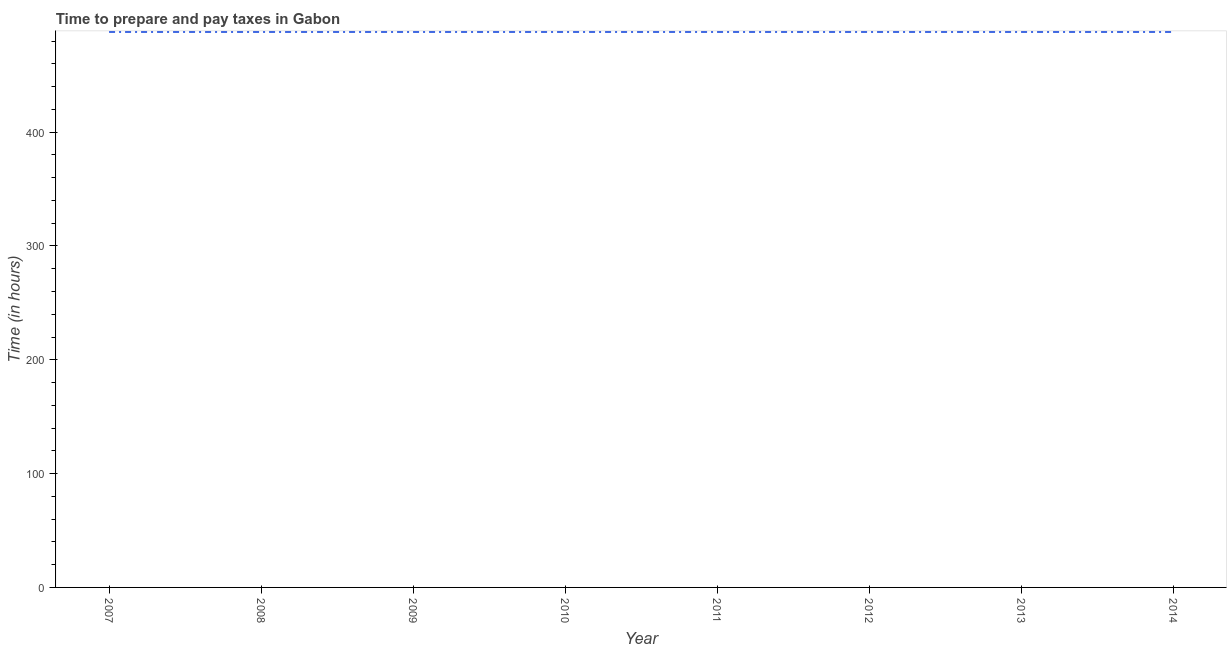What is the time to prepare and pay taxes in 2014?
Offer a very short reply. 488. Across all years, what is the maximum time to prepare and pay taxes?
Offer a very short reply. 488. Across all years, what is the minimum time to prepare and pay taxes?
Offer a very short reply. 488. In which year was the time to prepare and pay taxes maximum?
Provide a succinct answer. 2007. What is the sum of the time to prepare and pay taxes?
Your response must be concise. 3904. What is the average time to prepare and pay taxes per year?
Give a very brief answer. 488. What is the median time to prepare and pay taxes?
Give a very brief answer. 488. In how many years, is the time to prepare and pay taxes greater than 420 hours?
Your response must be concise. 8. Do a majority of the years between 2009 and 2011 (inclusive) have time to prepare and pay taxes greater than 260 hours?
Make the answer very short. Yes. What is the ratio of the time to prepare and pay taxes in 2008 to that in 2014?
Offer a terse response. 1. Is the time to prepare and pay taxes in 2009 less than that in 2011?
Give a very brief answer. No. What is the difference between the highest and the lowest time to prepare and pay taxes?
Ensure brevity in your answer.  0. How many years are there in the graph?
Provide a succinct answer. 8. Does the graph contain any zero values?
Ensure brevity in your answer.  No. What is the title of the graph?
Offer a very short reply. Time to prepare and pay taxes in Gabon. What is the label or title of the X-axis?
Your answer should be compact. Year. What is the label or title of the Y-axis?
Give a very brief answer. Time (in hours). What is the Time (in hours) of 2007?
Give a very brief answer. 488. What is the Time (in hours) of 2008?
Give a very brief answer. 488. What is the Time (in hours) in 2009?
Provide a short and direct response. 488. What is the Time (in hours) of 2010?
Your answer should be compact. 488. What is the Time (in hours) of 2011?
Provide a short and direct response. 488. What is the Time (in hours) in 2012?
Provide a short and direct response. 488. What is the Time (in hours) in 2013?
Your answer should be compact. 488. What is the Time (in hours) of 2014?
Offer a very short reply. 488. What is the difference between the Time (in hours) in 2007 and 2010?
Provide a succinct answer. 0. What is the difference between the Time (in hours) in 2007 and 2011?
Provide a succinct answer. 0. What is the difference between the Time (in hours) in 2007 and 2012?
Provide a succinct answer. 0. What is the difference between the Time (in hours) in 2007 and 2013?
Provide a succinct answer. 0. What is the difference between the Time (in hours) in 2008 and 2009?
Provide a succinct answer. 0. What is the difference between the Time (in hours) in 2008 and 2010?
Your answer should be very brief. 0. What is the difference between the Time (in hours) in 2008 and 2011?
Give a very brief answer. 0. What is the difference between the Time (in hours) in 2008 and 2012?
Ensure brevity in your answer.  0. What is the difference between the Time (in hours) in 2008 and 2013?
Your answer should be very brief. 0. What is the difference between the Time (in hours) in 2009 and 2014?
Offer a very short reply. 0. What is the difference between the Time (in hours) in 2010 and 2011?
Make the answer very short. 0. What is the difference between the Time (in hours) in 2010 and 2013?
Your response must be concise. 0. What is the difference between the Time (in hours) in 2011 and 2014?
Provide a short and direct response. 0. What is the difference between the Time (in hours) in 2012 and 2013?
Your answer should be very brief. 0. What is the difference between the Time (in hours) in 2012 and 2014?
Your answer should be very brief. 0. What is the ratio of the Time (in hours) in 2007 to that in 2010?
Ensure brevity in your answer.  1. What is the ratio of the Time (in hours) in 2007 to that in 2011?
Your response must be concise. 1. What is the ratio of the Time (in hours) in 2007 to that in 2012?
Make the answer very short. 1. What is the ratio of the Time (in hours) in 2007 to that in 2013?
Make the answer very short. 1. What is the ratio of the Time (in hours) in 2007 to that in 2014?
Your answer should be very brief. 1. What is the ratio of the Time (in hours) in 2008 to that in 2011?
Offer a very short reply. 1. What is the ratio of the Time (in hours) in 2008 to that in 2013?
Offer a very short reply. 1. What is the ratio of the Time (in hours) in 2008 to that in 2014?
Keep it short and to the point. 1. What is the ratio of the Time (in hours) in 2009 to that in 2011?
Offer a terse response. 1. What is the ratio of the Time (in hours) in 2009 to that in 2012?
Offer a terse response. 1. What is the ratio of the Time (in hours) in 2009 to that in 2013?
Offer a terse response. 1. What is the ratio of the Time (in hours) in 2010 to that in 2011?
Your response must be concise. 1. What is the ratio of the Time (in hours) in 2010 to that in 2012?
Provide a succinct answer. 1. What is the ratio of the Time (in hours) in 2011 to that in 2012?
Keep it short and to the point. 1. What is the ratio of the Time (in hours) in 2011 to that in 2013?
Provide a succinct answer. 1. What is the ratio of the Time (in hours) in 2011 to that in 2014?
Provide a succinct answer. 1. What is the ratio of the Time (in hours) in 2012 to that in 2013?
Offer a terse response. 1. What is the ratio of the Time (in hours) in 2012 to that in 2014?
Offer a very short reply. 1. What is the ratio of the Time (in hours) in 2013 to that in 2014?
Provide a short and direct response. 1. 